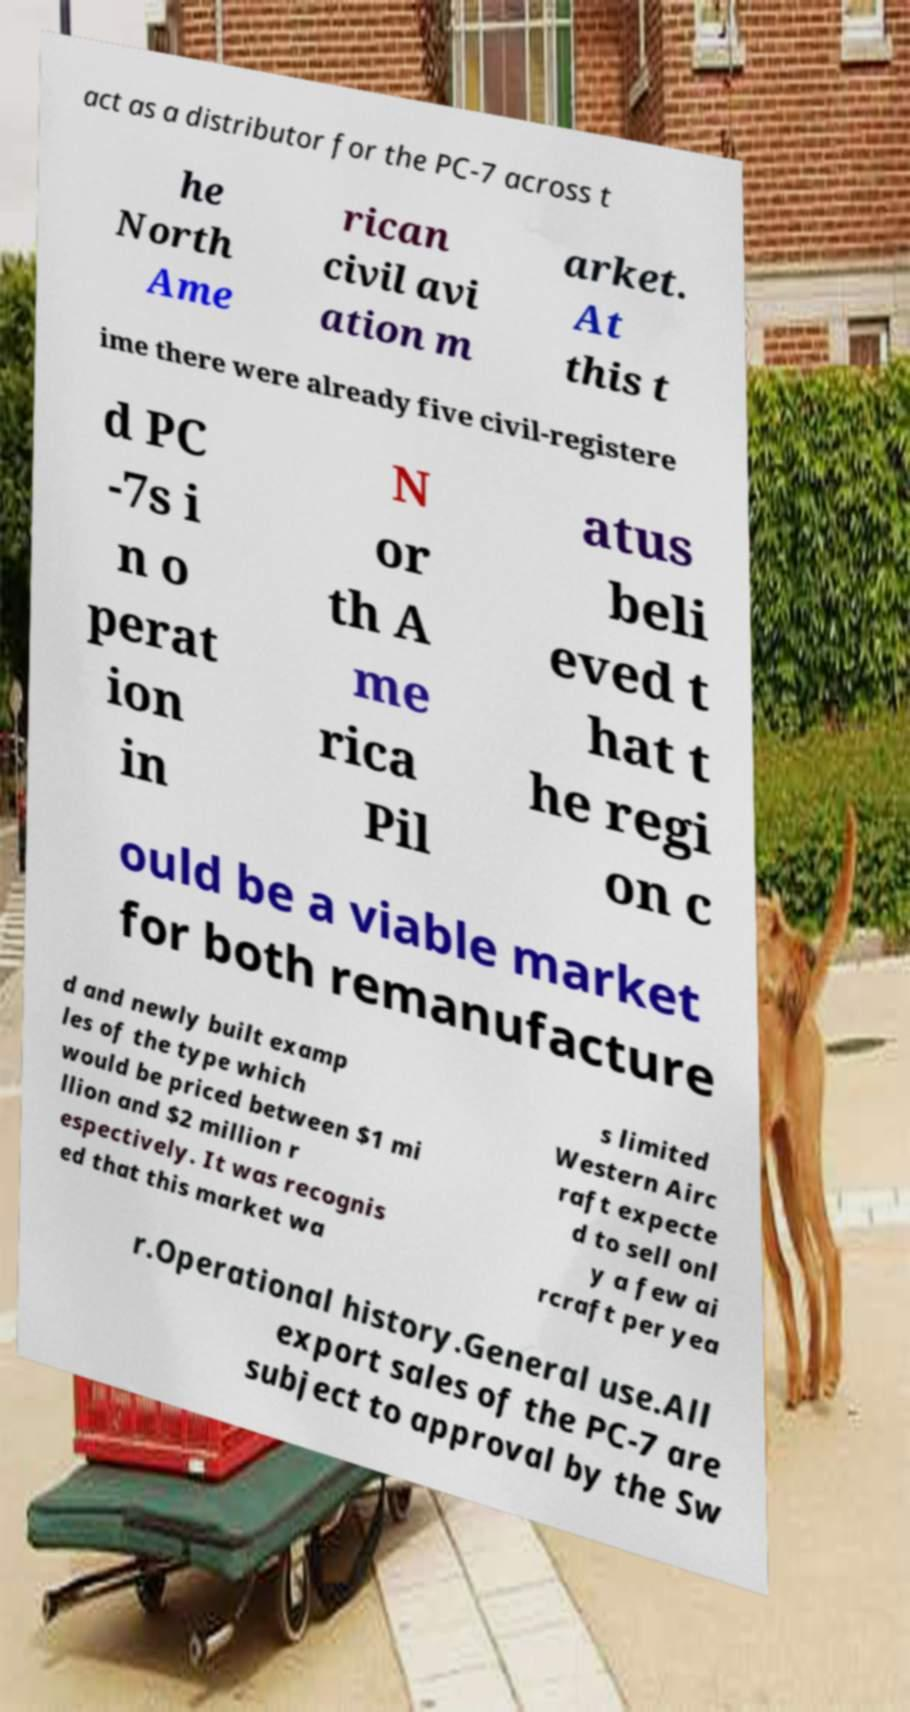Could you extract and type out the text from this image? act as a distributor for the PC-7 across t he North Ame rican civil avi ation m arket. At this t ime there were already five civil-registere d PC -7s i n o perat ion in N or th A me rica Pil atus beli eved t hat t he regi on c ould be a viable market for both remanufacture d and newly built examp les of the type which would be priced between $1 mi llion and $2 million r espectively. It was recognis ed that this market wa s limited Western Airc raft expecte d to sell onl y a few ai rcraft per yea r.Operational history.General use.All export sales of the PC-7 are subject to approval by the Sw 